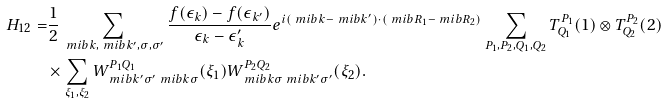<formula> <loc_0><loc_0><loc_500><loc_500>H _ { 1 2 } = & \frac { 1 } { 2 } \sum _ { \ m i b { k } , \ m i b { k } ^ { \prime } , \sigma , \sigma ^ { \prime } } \frac { f ( \epsilon _ { k } ) - f ( \epsilon _ { k ^ { \prime } } ) } { \epsilon _ { k } - \epsilon _ { k } ^ { \prime } } e ^ { i ( \ m i b { k } - \ m i b { k } ^ { \prime } ) \cdot ( \ m i b { R } _ { 1 } - \ m i b { R } _ { 2 } ) } \sum _ { P _ { 1 } , P _ { 2 } , Q _ { 1 } , Q _ { 2 } } T _ { Q _ { 1 } } ^ { P _ { 1 } } ( 1 ) \otimes T _ { Q _ { 2 } } ^ { P _ { 2 } } ( 2 ) \\ & \times \sum _ { \xi _ { 1 } , \xi _ { 2 } } W _ { \ m i b { k } ^ { \prime } \sigma ^ { \prime } \ m i b { k } \sigma } ^ { P _ { 1 } Q _ { 1 } } ( \xi _ { 1 } ) W _ { \ m i b { k } \sigma \ m i b { k } ^ { \prime } \sigma ^ { \prime } } ^ { P _ { 2 } Q _ { 2 } } ( \xi _ { 2 } ) .</formula> 